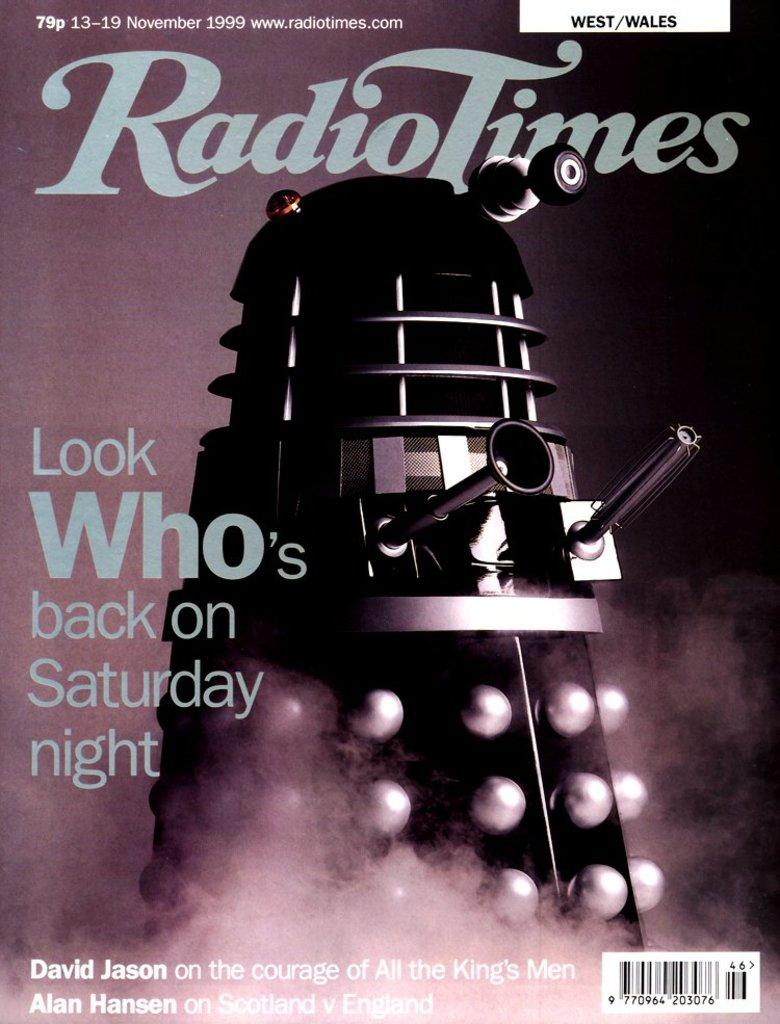<image>
Create a compact narrative representing the image presented. A magazine cover that says Radio Times with the title Look Who's back on Saturday Night 